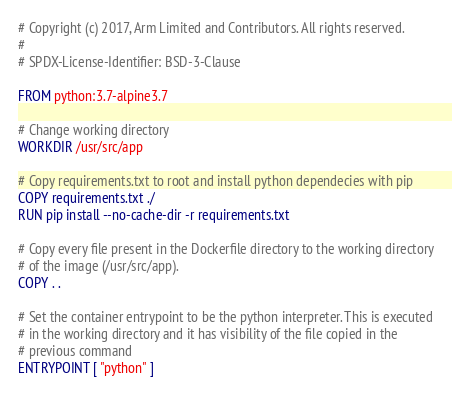Convert code to text. <code><loc_0><loc_0><loc_500><loc_500><_Dockerfile_># Copyright (c) 2017, Arm Limited and Contributors. All rights reserved.
#
# SPDX-License-Identifier: BSD-3-Clause

FROM python:3.7-alpine3.7

# Change working directory
WORKDIR /usr/src/app

# Copy requirements.txt to root and install python dependecies with pip
COPY requirements.txt ./
RUN pip install --no-cache-dir -r requirements.txt

# Copy every file present in the Dockerfile directory to the working directory
# of the image (/usr/src/app).
COPY . .

# Set the container entrypoint to be the python interpreter. This is executed
# in the working directory and it has visibility of the file copied in the
# previous command
ENTRYPOINT [ "python" ]
</code> 